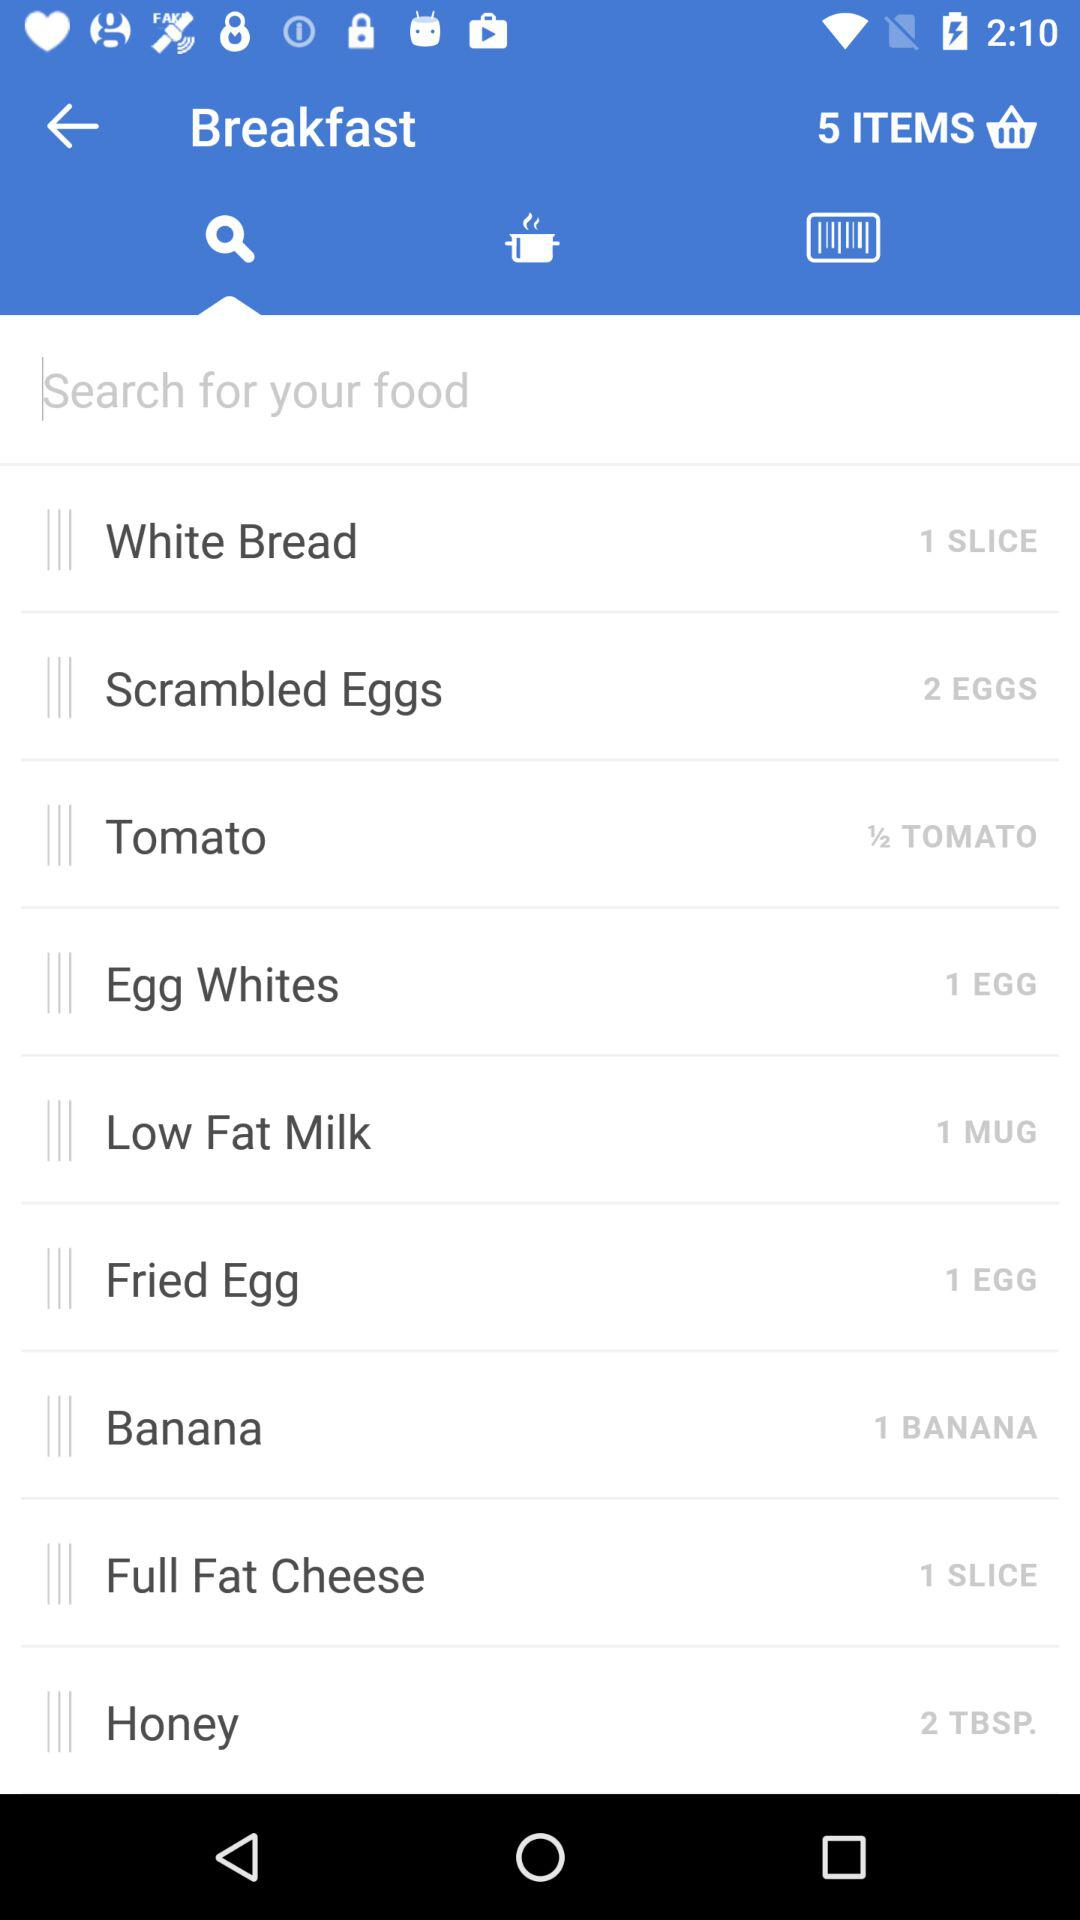How many slices of white bread are displayed there? There is 1 slice of white bread displayed there. 